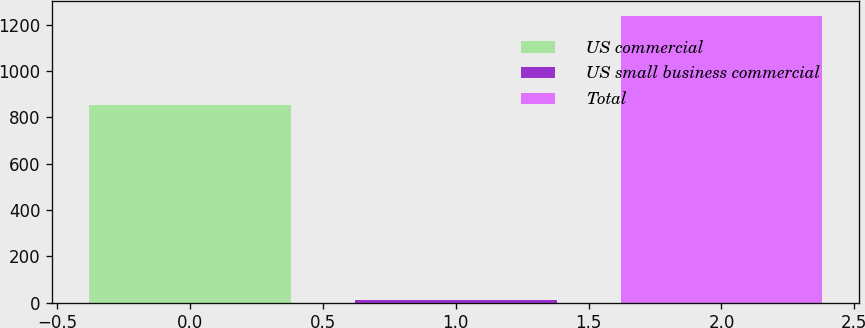Convert chart to OTSL. <chart><loc_0><loc_0><loc_500><loc_500><bar_chart><fcel>US commercial<fcel>US small business commercial<fcel>Total<nl><fcel>853<fcel>14<fcel>1238<nl></chart> 